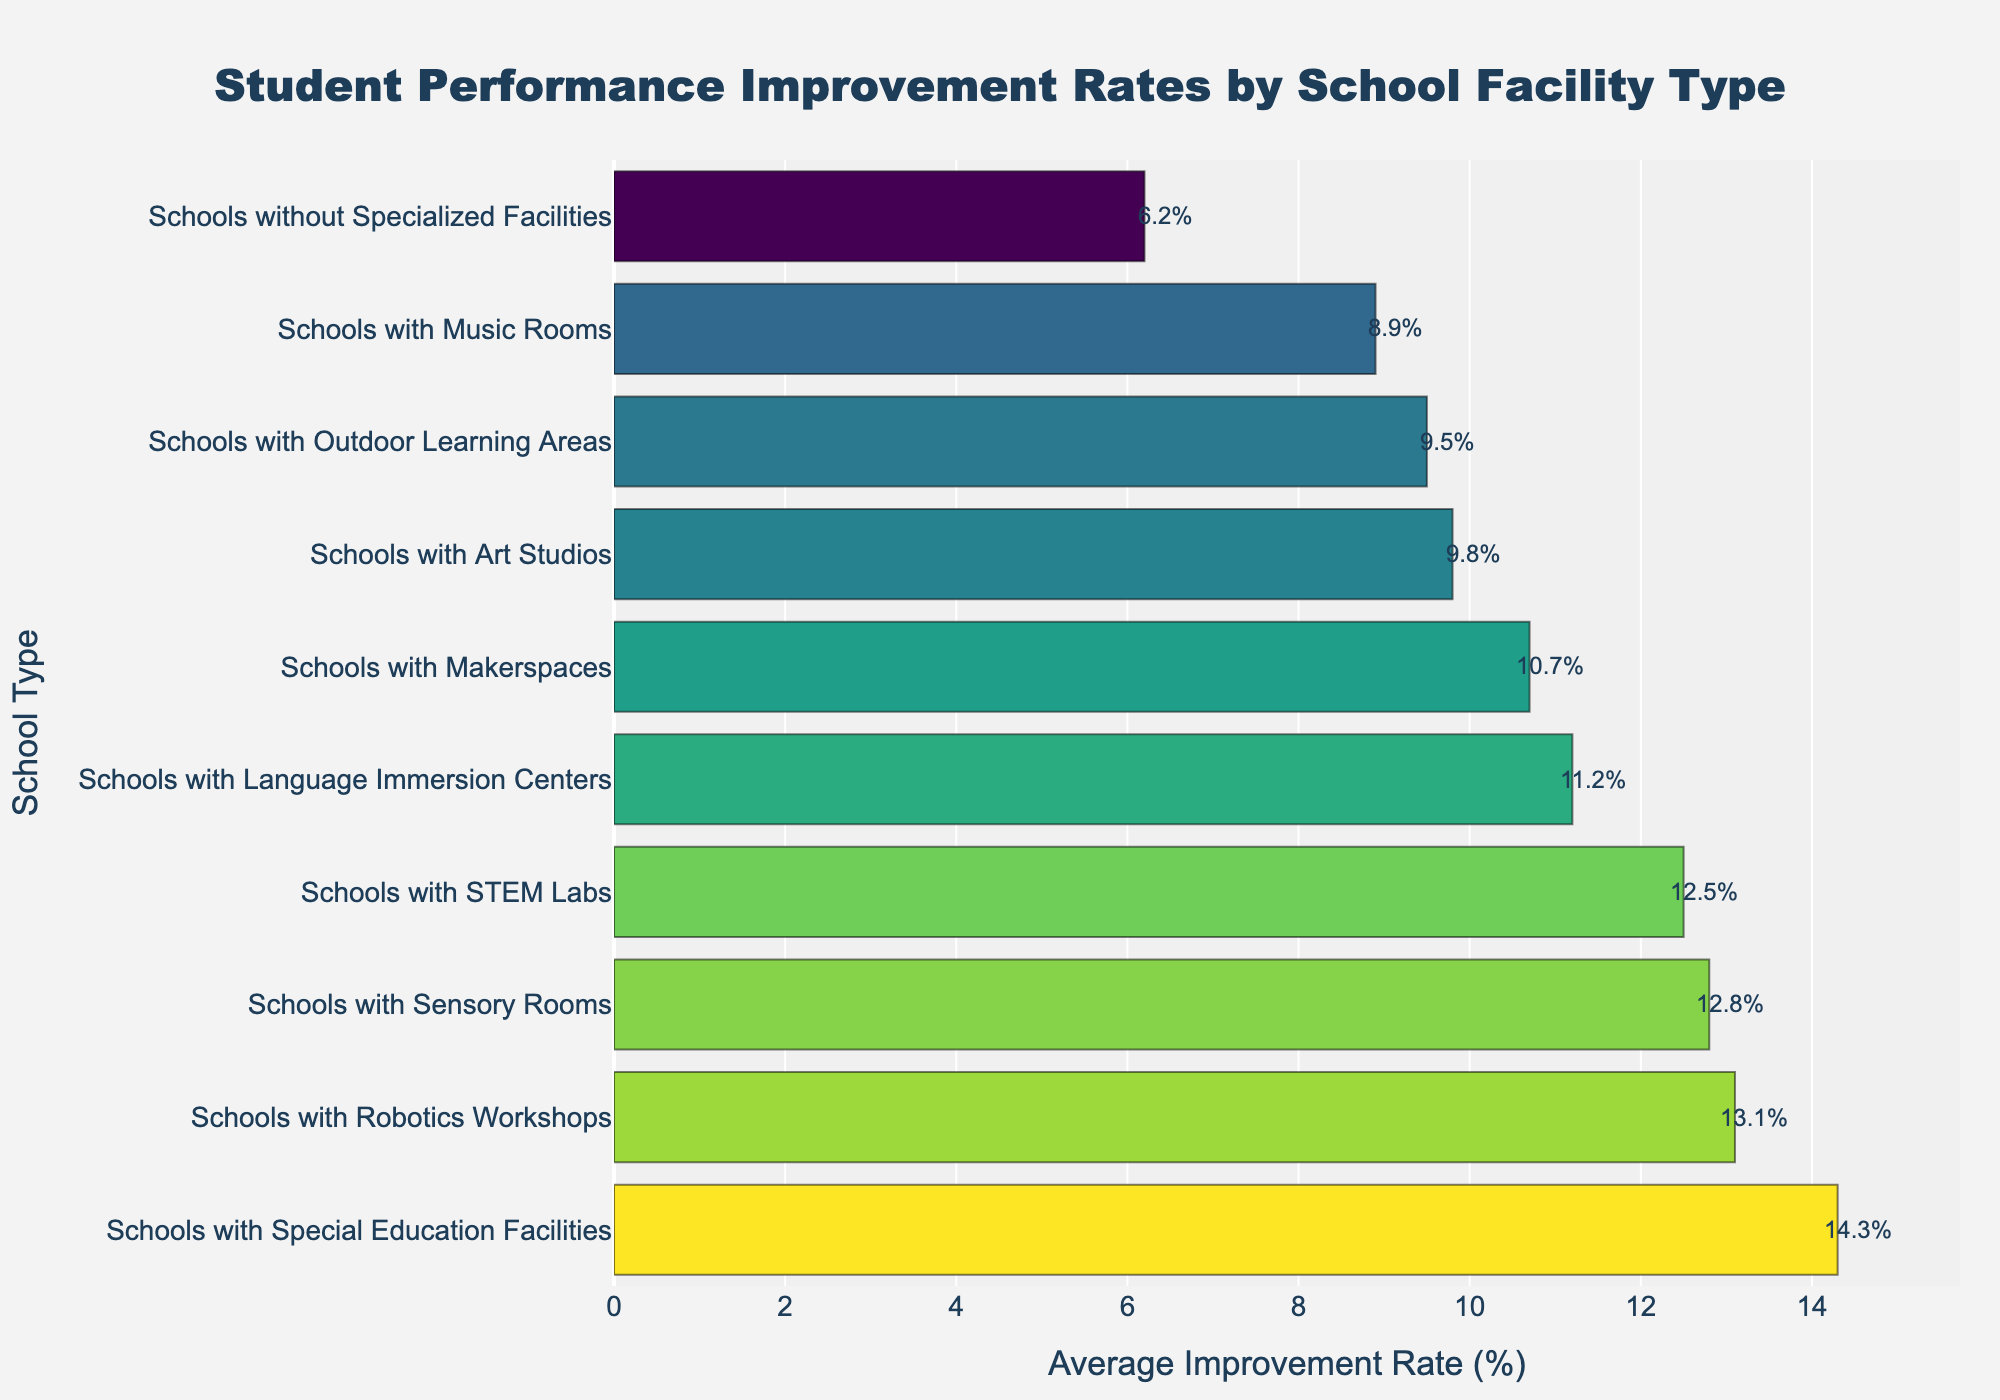Which school facility type has the highest student performance improvement rate? The bar representing "Schools with Special Education Facilities" is the longest, indicating the highest average improvement rate of 14.3%.
Answer: Schools with Special Education Facilities What is the difference in the improvement rate between schools with special education facilities and schools without specialized facilities? From the figure, schools with special education facilities have an improvement rate of 14.3%, while schools without specialized facilities have 6.2%. The difference is 14.3% - 6.2% = 8.1%.
Answer: 8.1% Which school facility type has the closest improvement rate to 10%? The bar for "Schools with Makerspaces" shows an improvement rate of 10.7%, which is closest to 10%.
Answer: Schools with Makerspaces How many school facility types have improvement rates above the overall average (calculated across all provided categories)? The averages given are: 12.5, 9.8, 11.2, 14.3, 10.7, 6.2, 8.9, 13.1, 9.5, and 12.8. The median value (since it's a reasonable estimate for average) is calculated by sorting the values (6.2, 8.9, 9.5, 9.8, 10.7, 11.2, 12.5, 12.8, 13.1, 14.3). The median is (10.7+11.2)/2 = 10.95. Facilities with rates above 10.95% are special education facilities, STEM labs, language immersion centers, robotics workshops, and sensory rooms. This counts to 5 types.
Answer: 5 Compare the improvement rates between schools with sensory rooms and music rooms. Which has a higher rate and by how much? Schools with sensory rooms have an improvement rate of 12.8%, whereas schools with music rooms have 8.9%. The difference is 12.8% - 8.9% = 3.9%, and sensory rooms have the higher rate.
Answer: Sensory rooms by 3.9% Which school facility type has the lowest student performance improvement rate? The bar representing "Schools without Specialized Facilities" is the shortest, indicating the lowest average improvement rate of 6.2%.
Answer: Schools without Specialized Facilities What is the combined average improvement rate of schools with STEM labs and robotics workshops? The average improvement rate of schools with STEM labs is 12.5% and for schools with robotics workshops is 13.1%. The combined average is (12.5% + 13.1%) / 2 = 12.8%.
Answer: 12.8% Which has a larger improvement rate: Schools with art studios or schools with outdoor learning areas, and by how much? Schools with art studios have an improvement rate of 9.8%, while schools with outdoor learning areas have 9.5%. The difference is 9.8% - 9.5% = 0.3%, with art studios having the higher rate.
Answer: Art studios by 0.3% 